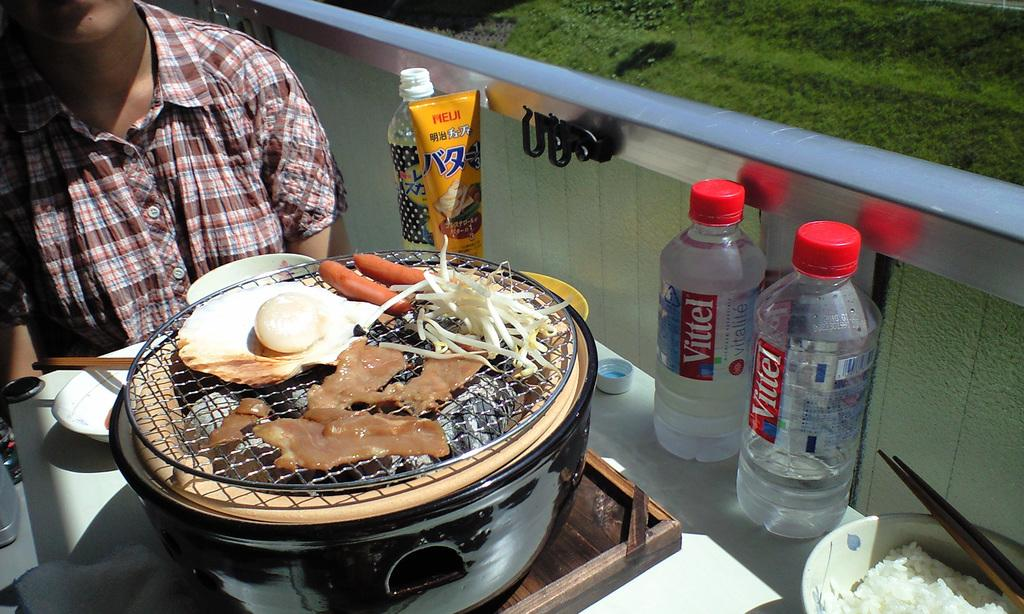What is the man in the image doing? The man is sitting in the image. Where is the man sitting in relation to the table? The man is sitting in front of a table. What can be found on the table in the image? There is a bowl of food and a water bottle on the table. What month is it in the image? The month cannot be determined from the image, as there is no information about the date or time of year. What type of plant is growing on the table in the image? There are no plants visible on the table in the image. 